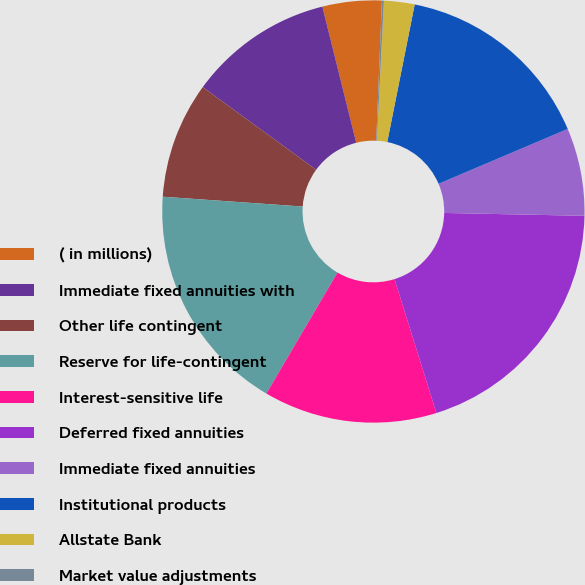Convert chart to OTSL. <chart><loc_0><loc_0><loc_500><loc_500><pie_chart><fcel>( in millions)<fcel>Immediate fixed annuities with<fcel>Other life contingent<fcel>Reserve for life-contingent<fcel>Interest-sensitive life<fcel>Deferred fixed annuities<fcel>Immediate fixed annuities<fcel>Institutional products<fcel>Allstate Bank<fcel>Market value adjustments<nl><fcel>4.53%<fcel>11.09%<fcel>8.91%<fcel>17.66%<fcel>13.28%<fcel>19.85%<fcel>6.72%<fcel>15.47%<fcel>2.34%<fcel>0.15%<nl></chart> 